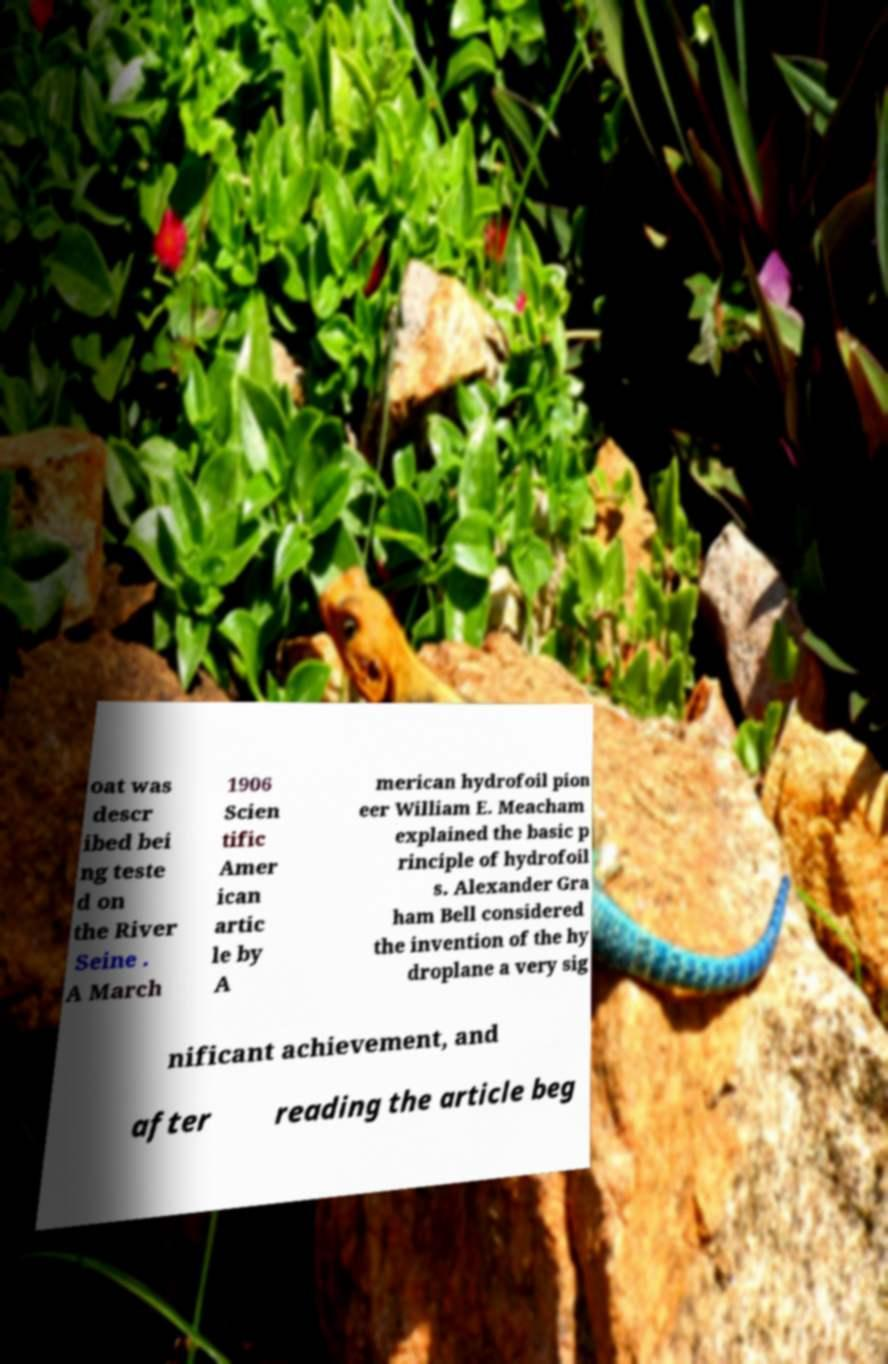Please identify and transcribe the text found in this image. oat was descr ibed bei ng teste d on the River Seine . A March 1906 Scien tific Amer ican artic le by A merican hydrofoil pion eer William E. Meacham explained the basic p rinciple of hydrofoil s. Alexander Gra ham Bell considered the invention of the hy droplane a very sig nificant achievement, and after reading the article beg 